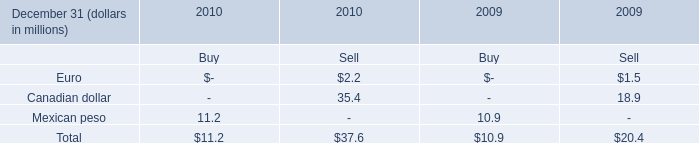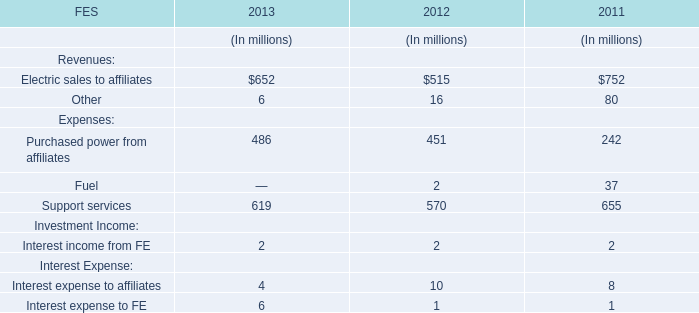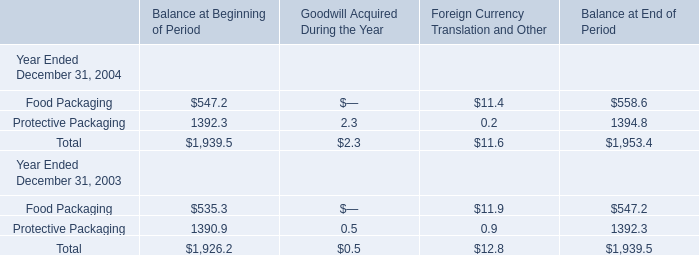If Food Packaging for Balance at End of Period develops with the same growth rate in 2004, what will it reach in 2005? 
Computations: (558.6 * (1 + ((558.6 - 547.2) / 547.2)))
Answer: 570.2375. 